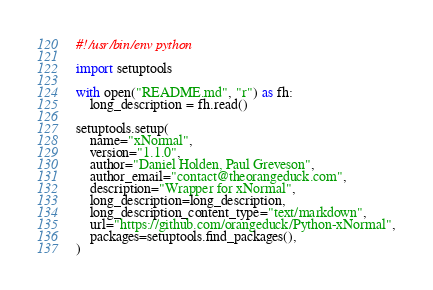<code> <loc_0><loc_0><loc_500><loc_500><_Python_>#!/usr/bin/env python

import setuptools

with open("README.md", "r") as fh:
    long_description = fh.read()

setuptools.setup(
    name="xNormal",
    version="1.1.0",
    author="Daniel Holden, Paul Greveson",
    author_email="contact@theorangeduck.com",
    description="Wrapper for xNormal",
    long_description=long_description,
    long_description_content_type="text/markdown",
    url="https://github.com/orangeduck/Python-xNormal",
    packages=setuptools.find_packages(),
)</code> 